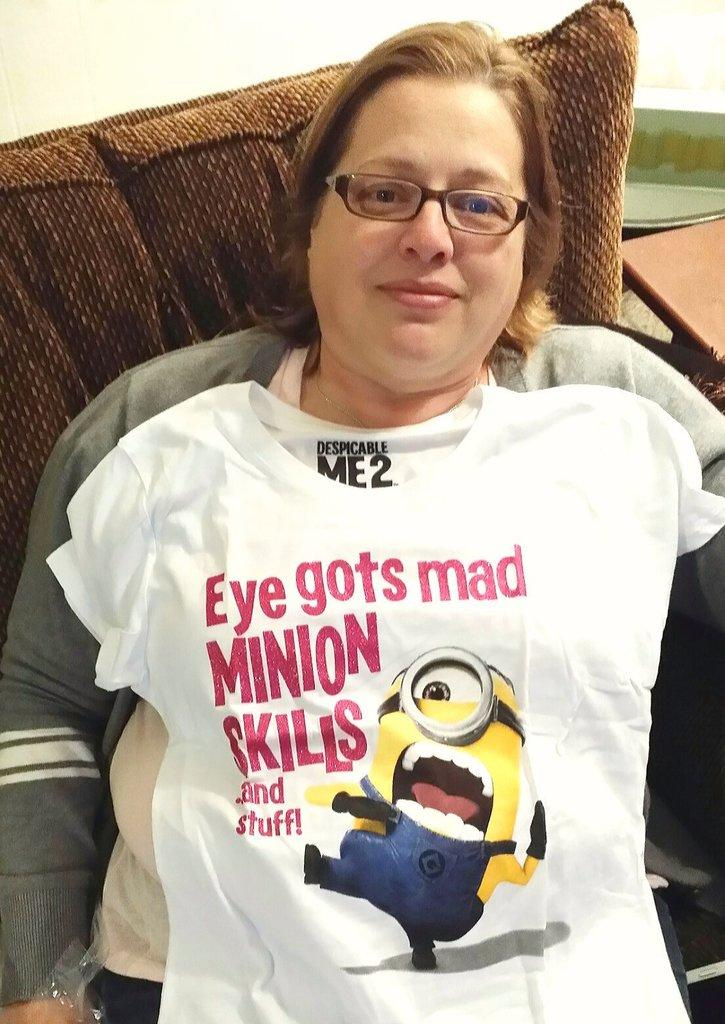Who is the main subject in the image? There is a woman in the image. What is the woman doing in the image? The woman is sitting on a chair. What is the woman wearing in the image? The woman is wearing a white T-shirt. What type of berry can be seen growing on the woman's T-shirt in the image? There are no berries present on the woman's T-shirt in the image. 